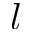Convert formula to latex. <formula><loc_0><loc_0><loc_500><loc_500>l</formula> 